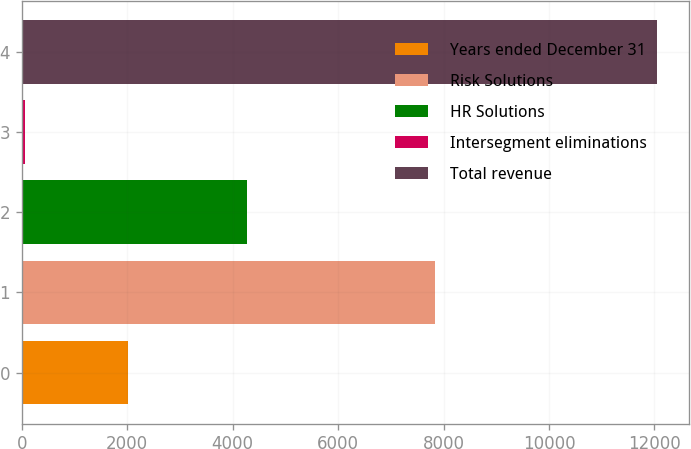Convert chart to OTSL. <chart><loc_0><loc_0><loc_500><loc_500><bar_chart><fcel>Years ended December 31<fcel>Risk Solutions<fcel>HR Solutions<fcel>Intersegment eliminations<fcel>Total revenue<nl><fcel>2014<fcel>7834<fcel>4264<fcel>53<fcel>12045<nl></chart> 